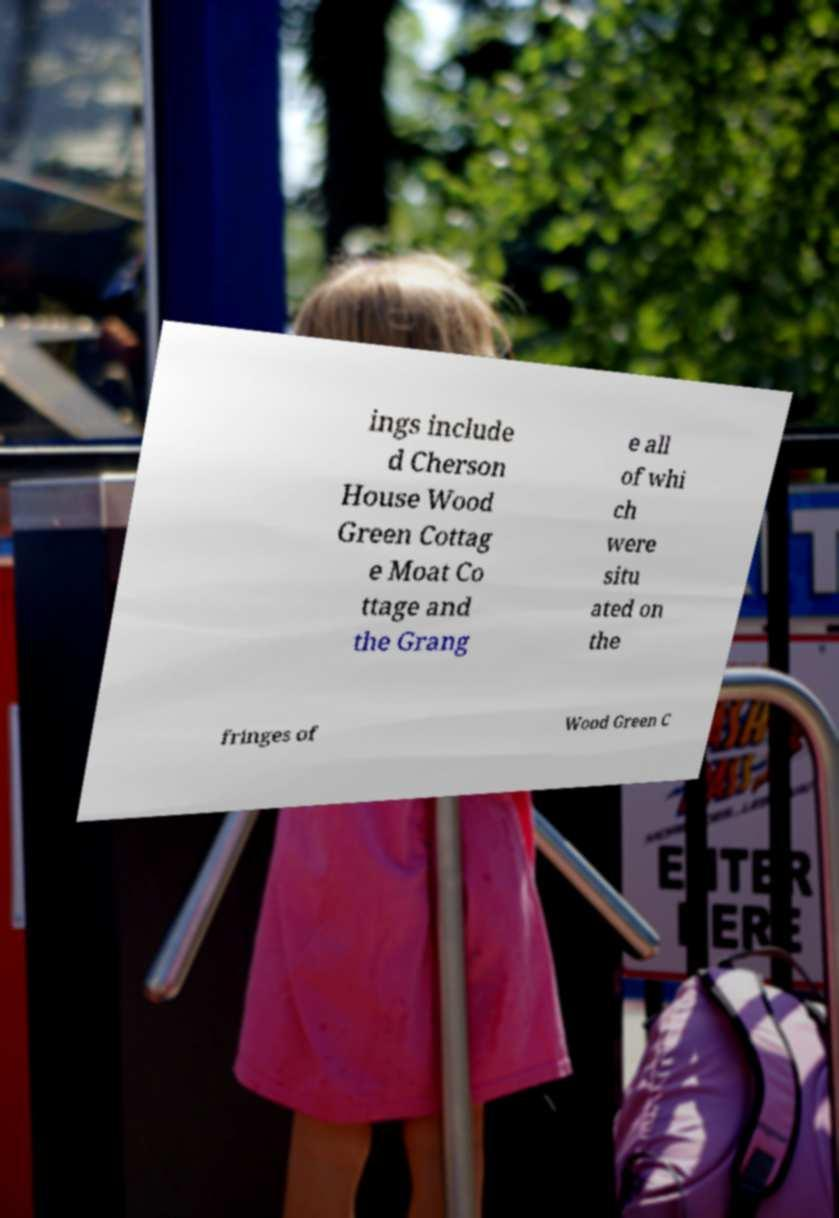There's text embedded in this image that I need extracted. Can you transcribe it verbatim? ings include d Cherson House Wood Green Cottag e Moat Co ttage and the Grang e all of whi ch were situ ated on the fringes of Wood Green C 